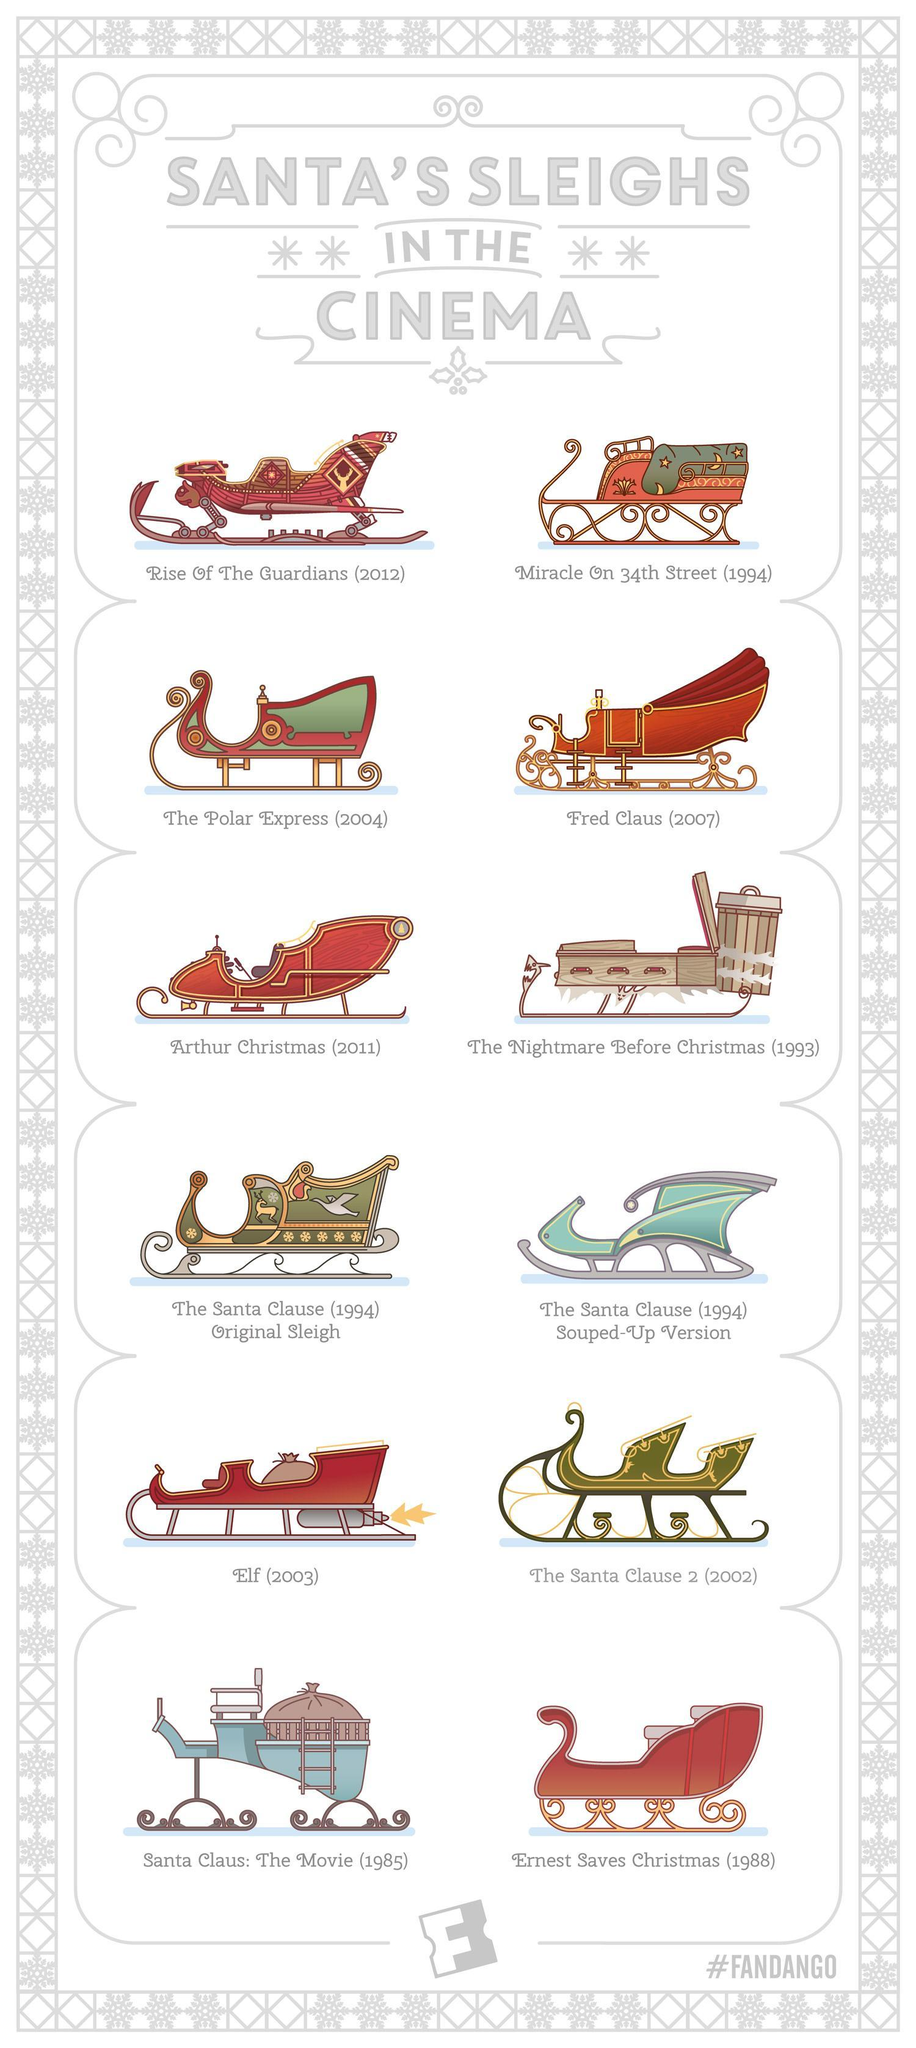how many handles in the body of the sleigh in the movie the Nightmare before Christmas
Answer the question with a short phrase. 3 WHich movies were released in 1994 Miracle on 34th Street, The Santa Clause (1994) Original Sleigh. The Santa Clause (1994) Souped-up Version what is the colour of the sleigh in the Santa Clause 2, green or blue green the sleigh in which movie has a bin attached at the back the nightmare before christmas where were this movies shown cinema Sleighs in which moves have bags shown inside Santa Claus: The Movie, Elf 